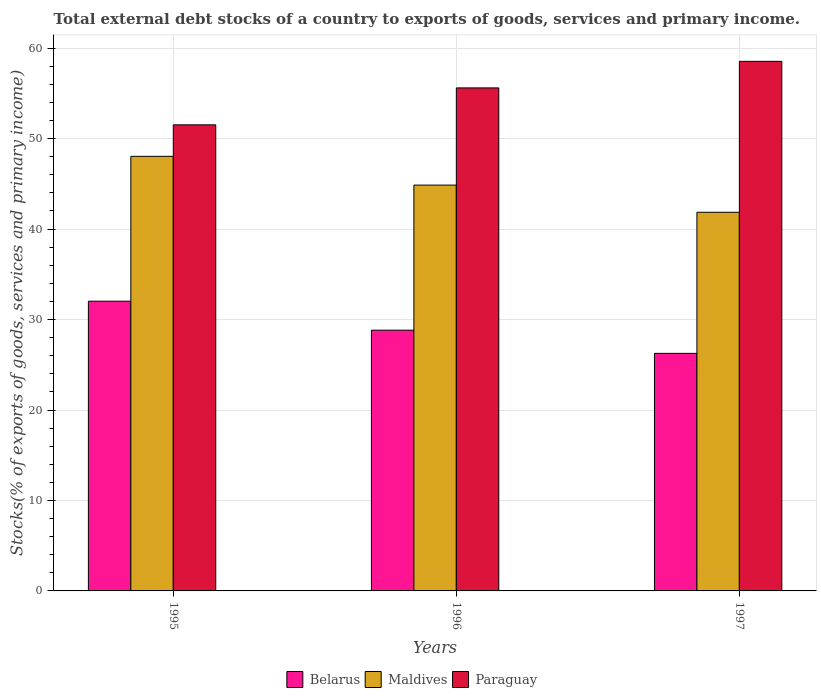How many different coloured bars are there?
Offer a very short reply. 3. How many groups of bars are there?
Your answer should be compact. 3. Are the number of bars on each tick of the X-axis equal?
Give a very brief answer. Yes. What is the label of the 2nd group of bars from the left?
Ensure brevity in your answer.  1996. In how many cases, is the number of bars for a given year not equal to the number of legend labels?
Give a very brief answer. 0. What is the total debt stocks in Maldives in 1997?
Your response must be concise. 41.86. Across all years, what is the maximum total debt stocks in Belarus?
Ensure brevity in your answer.  32.03. Across all years, what is the minimum total debt stocks in Maldives?
Give a very brief answer. 41.86. In which year was the total debt stocks in Maldives minimum?
Your answer should be compact. 1997. What is the total total debt stocks in Belarus in the graph?
Give a very brief answer. 87.12. What is the difference between the total debt stocks in Maldives in 1996 and that in 1997?
Your answer should be compact. 3. What is the difference between the total debt stocks in Belarus in 1997 and the total debt stocks in Paraguay in 1995?
Offer a terse response. -25.26. What is the average total debt stocks in Paraguay per year?
Keep it short and to the point. 55.23. In the year 1997, what is the difference between the total debt stocks in Maldives and total debt stocks in Paraguay?
Provide a short and direct response. -16.68. In how many years, is the total debt stocks in Maldives greater than 22 %?
Offer a terse response. 3. What is the ratio of the total debt stocks in Maldives in 1996 to that in 1997?
Provide a short and direct response. 1.07. Is the total debt stocks in Maldives in 1996 less than that in 1997?
Keep it short and to the point. No. What is the difference between the highest and the second highest total debt stocks in Paraguay?
Provide a succinct answer. 2.93. What is the difference between the highest and the lowest total debt stocks in Maldives?
Your answer should be very brief. 6.18. In how many years, is the total debt stocks in Maldives greater than the average total debt stocks in Maldives taken over all years?
Offer a terse response. 1. Is the sum of the total debt stocks in Paraguay in 1995 and 1997 greater than the maximum total debt stocks in Maldives across all years?
Your answer should be very brief. Yes. What does the 1st bar from the left in 1996 represents?
Your answer should be compact. Belarus. What does the 3rd bar from the right in 1997 represents?
Your answer should be compact. Belarus. How many bars are there?
Your answer should be compact. 9. How many years are there in the graph?
Your answer should be very brief. 3. What is the difference between two consecutive major ticks on the Y-axis?
Make the answer very short. 10. Does the graph contain any zero values?
Ensure brevity in your answer.  No. Where does the legend appear in the graph?
Your answer should be compact. Bottom center. How many legend labels are there?
Provide a succinct answer. 3. How are the legend labels stacked?
Keep it short and to the point. Horizontal. What is the title of the graph?
Provide a short and direct response. Total external debt stocks of a country to exports of goods, services and primary income. What is the label or title of the Y-axis?
Your response must be concise. Stocks(% of exports of goods, services and primary income). What is the Stocks(% of exports of goods, services and primary income) in Belarus in 1995?
Provide a short and direct response. 32.03. What is the Stocks(% of exports of goods, services and primary income) in Maldives in 1995?
Provide a succinct answer. 48.04. What is the Stocks(% of exports of goods, services and primary income) of Paraguay in 1995?
Offer a terse response. 51.52. What is the Stocks(% of exports of goods, services and primary income) of Belarus in 1996?
Provide a short and direct response. 28.82. What is the Stocks(% of exports of goods, services and primary income) in Maldives in 1996?
Provide a succinct answer. 44.86. What is the Stocks(% of exports of goods, services and primary income) of Paraguay in 1996?
Your answer should be very brief. 55.61. What is the Stocks(% of exports of goods, services and primary income) in Belarus in 1997?
Your answer should be compact. 26.26. What is the Stocks(% of exports of goods, services and primary income) of Maldives in 1997?
Keep it short and to the point. 41.86. What is the Stocks(% of exports of goods, services and primary income) of Paraguay in 1997?
Offer a very short reply. 58.54. Across all years, what is the maximum Stocks(% of exports of goods, services and primary income) of Belarus?
Your answer should be compact. 32.03. Across all years, what is the maximum Stocks(% of exports of goods, services and primary income) of Maldives?
Provide a short and direct response. 48.04. Across all years, what is the maximum Stocks(% of exports of goods, services and primary income) in Paraguay?
Make the answer very short. 58.54. Across all years, what is the minimum Stocks(% of exports of goods, services and primary income) in Belarus?
Ensure brevity in your answer.  26.26. Across all years, what is the minimum Stocks(% of exports of goods, services and primary income) of Maldives?
Your answer should be very brief. 41.86. Across all years, what is the minimum Stocks(% of exports of goods, services and primary income) in Paraguay?
Offer a very short reply. 51.52. What is the total Stocks(% of exports of goods, services and primary income) in Belarus in the graph?
Keep it short and to the point. 87.12. What is the total Stocks(% of exports of goods, services and primary income) in Maldives in the graph?
Your answer should be very brief. 134.76. What is the total Stocks(% of exports of goods, services and primary income) of Paraguay in the graph?
Offer a very short reply. 165.68. What is the difference between the Stocks(% of exports of goods, services and primary income) in Belarus in 1995 and that in 1996?
Your response must be concise. 3.21. What is the difference between the Stocks(% of exports of goods, services and primary income) of Maldives in 1995 and that in 1996?
Make the answer very short. 3.18. What is the difference between the Stocks(% of exports of goods, services and primary income) in Paraguay in 1995 and that in 1996?
Keep it short and to the point. -4.08. What is the difference between the Stocks(% of exports of goods, services and primary income) in Belarus in 1995 and that in 1997?
Ensure brevity in your answer.  5.77. What is the difference between the Stocks(% of exports of goods, services and primary income) in Maldives in 1995 and that in 1997?
Provide a succinct answer. 6.18. What is the difference between the Stocks(% of exports of goods, services and primary income) in Paraguay in 1995 and that in 1997?
Your answer should be compact. -7.02. What is the difference between the Stocks(% of exports of goods, services and primary income) of Belarus in 1996 and that in 1997?
Offer a very short reply. 2.56. What is the difference between the Stocks(% of exports of goods, services and primary income) of Maldives in 1996 and that in 1997?
Keep it short and to the point. 3. What is the difference between the Stocks(% of exports of goods, services and primary income) of Paraguay in 1996 and that in 1997?
Provide a short and direct response. -2.93. What is the difference between the Stocks(% of exports of goods, services and primary income) in Belarus in 1995 and the Stocks(% of exports of goods, services and primary income) in Maldives in 1996?
Keep it short and to the point. -12.83. What is the difference between the Stocks(% of exports of goods, services and primary income) of Belarus in 1995 and the Stocks(% of exports of goods, services and primary income) of Paraguay in 1996?
Your response must be concise. -23.58. What is the difference between the Stocks(% of exports of goods, services and primary income) in Maldives in 1995 and the Stocks(% of exports of goods, services and primary income) in Paraguay in 1996?
Provide a succinct answer. -7.57. What is the difference between the Stocks(% of exports of goods, services and primary income) in Belarus in 1995 and the Stocks(% of exports of goods, services and primary income) in Maldives in 1997?
Provide a short and direct response. -9.83. What is the difference between the Stocks(% of exports of goods, services and primary income) in Belarus in 1995 and the Stocks(% of exports of goods, services and primary income) in Paraguay in 1997?
Make the answer very short. -26.51. What is the difference between the Stocks(% of exports of goods, services and primary income) in Maldives in 1995 and the Stocks(% of exports of goods, services and primary income) in Paraguay in 1997?
Keep it short and to the point. -10.5. What is the difference between the Stocks(% of exports of goods, services and primary income) of Belarus in 1996 and the Stocks(% of exports of goods, services and primary income) of Maldives in 1997?
Keep it short and to the point. -13.03. What is the difference between the Stocks(% of exports of goods, services and primary income) of Belarus in 1996 and the Stocks(% of exports of goods, services and primary income) of Paraguay in 1997?
Offer a terse response. -29.72. What is the difference between the Stocks(% of exports of goods, services and primary income) in Maldives in 1996 and the Stocks(% of exports of goods, services and primary income) in Paraguay in 1997?
Give a very brief answer. -13.68. What is the average Stocks(% of exports of goods, services and primary income) in Belarus per year?
Your answer should be very brief. 29.04. What is the average Stocks(% of exports of goods, services and primary income) of Maldives per year?
Provide a short and direct response. 44.92. What is the average Stocks(% of exports of goods, services and primary income) in Paraguay per year?
Your answer should be very brief. 55.23. In the year 1995, what is the difference between the Stocks(% of exports of goods, services and primary income) of Belarus and Stocks(% of exports of goods, services and primary income) of Maldives?
Make the answer very short. -16.01. In the year 1995, what is the difference between the Stocks(% of exports of goods, services and primary income) of Belarus and Stocks(% of exports of goods, services and primary income) of Paraguay?
Make the answer very short. -19.49. In the year 1995, what is the difference between the Stocks(% of exports of goods, services and primary income) of Maldives and Stocks(% of exports of goods, services and primary income) of Paraguay?
Keep it short and to the point. -3.48. In the year 1996, what is the difference between the Stocks(% of exports of goods, services and primary income) of Belarus and Stocks(% of exports of goods, services and primary income) of Maldives?
Give a very brief answer. -16.04. In the year 1996, what is the difference between the Stocks(% of exports of goods, services and primary income) of Belarus and Stocks(% of exports of goods, services and primary income) of Paraguay?
Offer a very short reply. -26.78. In the year 1996, what is the difference between the Stocks(% of exports of goods, services and primary income) of Maldives and Stocks(% of exports of goods, services and primary income) of Paraguay?
Ensure brevity in your answer.  -10.75. In the year 1997, what is the difference between the Stocks(% of exports of goods, services and primary income) of Belarus and Stocks(% of exports of goods, services and primary income) of Maldives?
Offer a very short reply. -15.6. In the year 1997, what is the difference between the Stocks(% of exports of goods, services and primary income) of Belarus and Stocks(% of exports of goods, services and primary income) of Paraguay?
Your answer should be very brief. -32.28. In the year 1997, what is the difference between the Stocks(% of exports of goods, services and primary income) in Maldives and Stocks(% of exports of goods, services and primary income) in Paraguay?
Ensure brevity in your answer.  -16.68. What is the ratio of the Stocks(% of exports of goods, services and primary income) in Belarus in 1995 to that in 1996?
Your response must be concise. 1.11. What is the ratio of the Stocks(% of exports of goods, services and primary income) of Maldives in 1995 to that in 1996?
Provide a short and direct response. 1.07. What is the ratio of the Stocks(% of exports of goods, services and primary income) of Paraguay in 1995 to that in 1996?
Offer a very short reply. 0.93. What is the ratio of the Stocks(% of exports of goods, services and primary income) of Belarus in 1995 to that in 1997?
Your answer should be compact. 1.22. What is the ratio of the Stocks(% of exports of goods, services and primary income) of Maldives in 1995 to that in 1997?
Offer a terse response. 1.15. What is the ratio of the Stocks(% of exports of goods, services and primary income) of Paraguay in 1995 to that in 1997?
Offer a terse response. 0.88. What is the ratio of the Stocks(% of exports of goods, services and primary income) of Belarus in 1996 to that in 1997?
Keep it short and to the point. 1.1. What is the ratio of the Stocks(% of exports of goods, services and primary income) in Maldives in 1996 to that in 1997?
Keep it short and to the point. 1.07. What is the ratio of the Stocks(% of exports of goods, services and primary income) of Paraguay in 1996 to that in 1997?
Provide a short and direct response. 0.95. What is the difference between the highest and the second highest Stocks(% of exports of goods, services and primary income) in Belarus?
Keep it short and to the point. 3.21. What is the difference between the highest and the second highest Stocks(% of exports of goods, services and primary income) in Maldives?
Your response must be concise. 3.18. What is the difference between the highest and the second highest Stocks(% of exports of goods, services and primary income) in Paraguay?
Your answer should be compact. 2.93. What is the difference between the highest and the lowest Stocks(% of exports of goods, services and primary income) in Belarus?
Provide a succinct answer. 5.77. What is the difference between the highest and the lowest Stocks(% of exports of goods, services and primary income) in Maldives?
Offer a terse response. 6.18. What is the difference between the highest and the lowest Stocks(% of exports of goods, services and primary income) of Paraguay?
Provide a succinct answer. 7.02. 